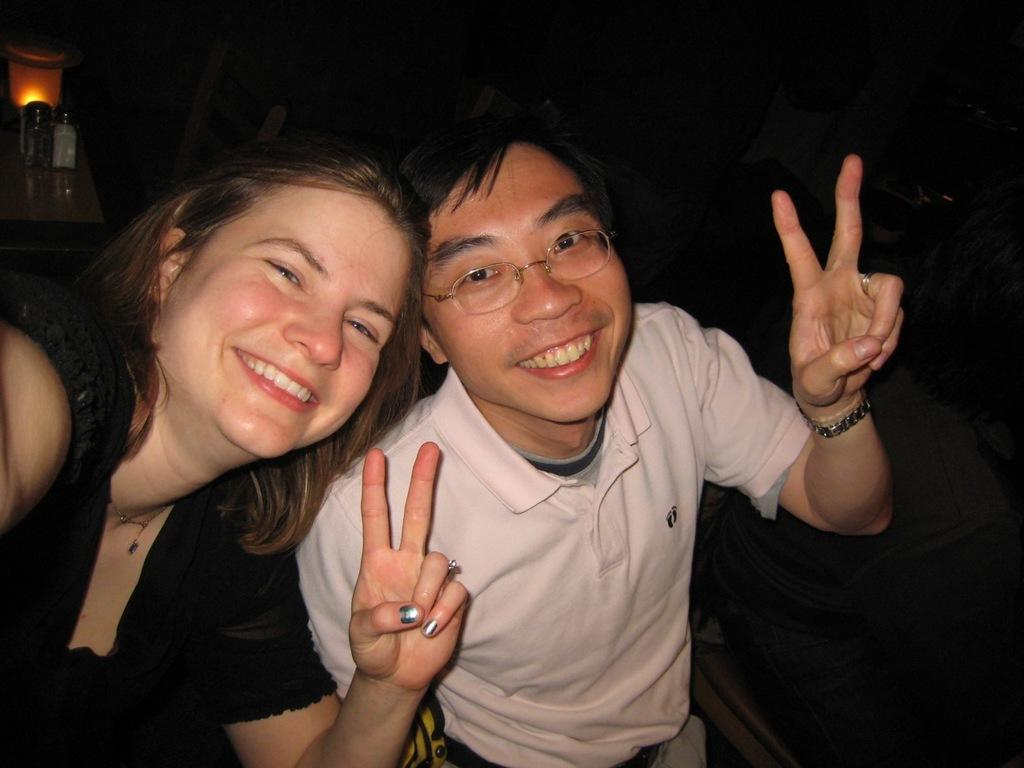How many people are in the image? There are two persons in the image. What is the facial expression of the persons in the image? The persons are smiling. What are the persons doing in the image? The persons are posing for a photo. What can be seen in the background of the image? There is a table in the background of the image. What is on the table in the image? There is a lamp on the table, and there are other unspecified items on the table. How many oranges are on the desk in the image? There is no desk present in the image, and therefore no oranges can be found on it. 